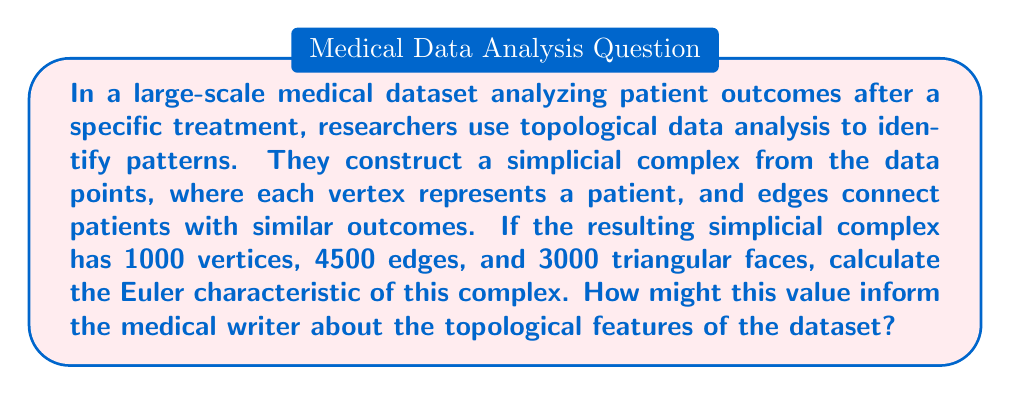Give your solution to this math problem. To solve this problem, we need to follow these steps:

1. Recall the formula for the Euler characteristic:
   The Euler characteristic $\chi$ of a simplicial complex is given by:
   
   $$\chi = V - E + F$$
   
   where $V$ is the number of vertices, $E$ is the number of edges, and $F$ is the number of faces.

2. Insert the given values into the formula:
   $V = 1000$ (vertices)
   $E = 4500$ (edges)
   $F = 3000$ (triangular faces)

3. Calculate the Euler characteristic:
   $$\chi = 1000 - 4500 + 3000 = -500$$

4. Interpret the result:
   The Euler characteristic is an important topological invariant. In this context:
   
   a) A negative Euler characteristic suggests that the simplicial complex has a non-trivial topology, potentially indicating complex relationships in the dataset.
   
   b) The magnitude of the Euler characteristic (-500) suggests a high degree of connectivity and complexity in the data structure.
   
   c) For the medical writer, this implies that the patient outcomes form intricate patterns that may not be easily discernible through traditional statistical methods.
   
   d) The negative value could indicate the presence of loops or holes in the data structure, which might represent subgroups of patients with distinct outcome patterns or cyclic relationships between variables.

5. Relevance to medical writing:
   Understanding this topological feature can help the medical writer to:
   - Emphasize the complexity of patient outcomes in their writing
   - Highlight the need for advanced analytical methods in interpreting the data
   - Suggest potential areas for further investigation, such as identifying specific subgroups of patients or exploring cyclic patterns in treatment outcomes
Answer: The Euler characteristic of the simplicial complex is $-500$. This negative value indicates a complex topology in the patient outcome data, suggesting intricate patterns and relationships that may require advanced analytical methods to fully understand and interpret in the context of medical research and treatment efficacy. 